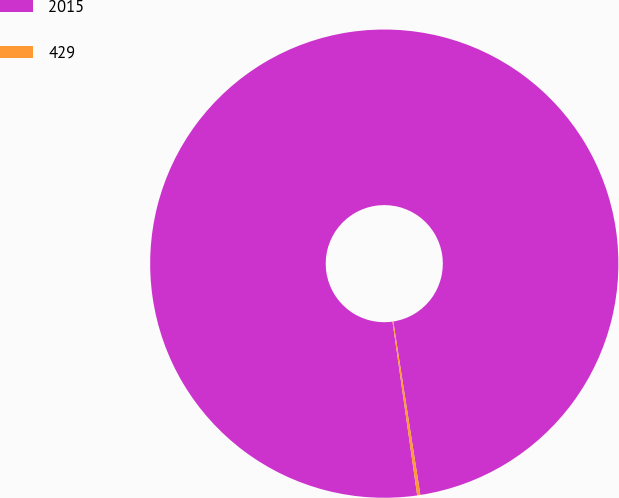<chart> <loc_0><loc_0><loc_500><loc_500><pie_chart><fcel>2015<fcel>429<nl><fcel>99.78%<fcel>0.22%<nl></chart> 